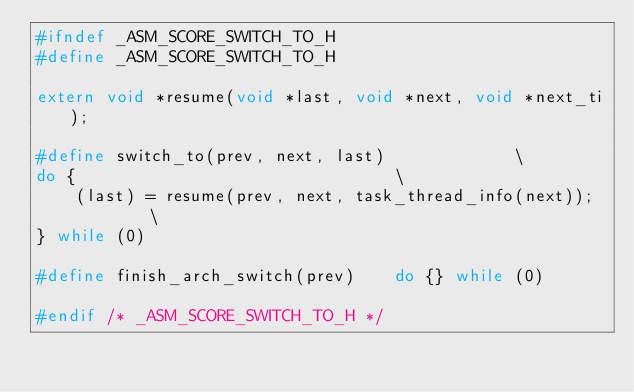<code> <loc_0><loc_0><loc_500><loc_500><_C_>#ifndef _ASM_SCORE_SWITCH_TO_H
#define _ASM_SCORE_SWITCH_TO_H

extern void *resume(void *last, void *next, void *next_ti);

#define switch_to(prev, next, last)				\
do {								\
	(last) = resume(prev, next, task_thread_info(next));	\
} while (0)

#define finish_arch_switch(prev)	do {} while (0)

#endif /* _ASM_SCORE_SWITCH_TO_H */
</code> 